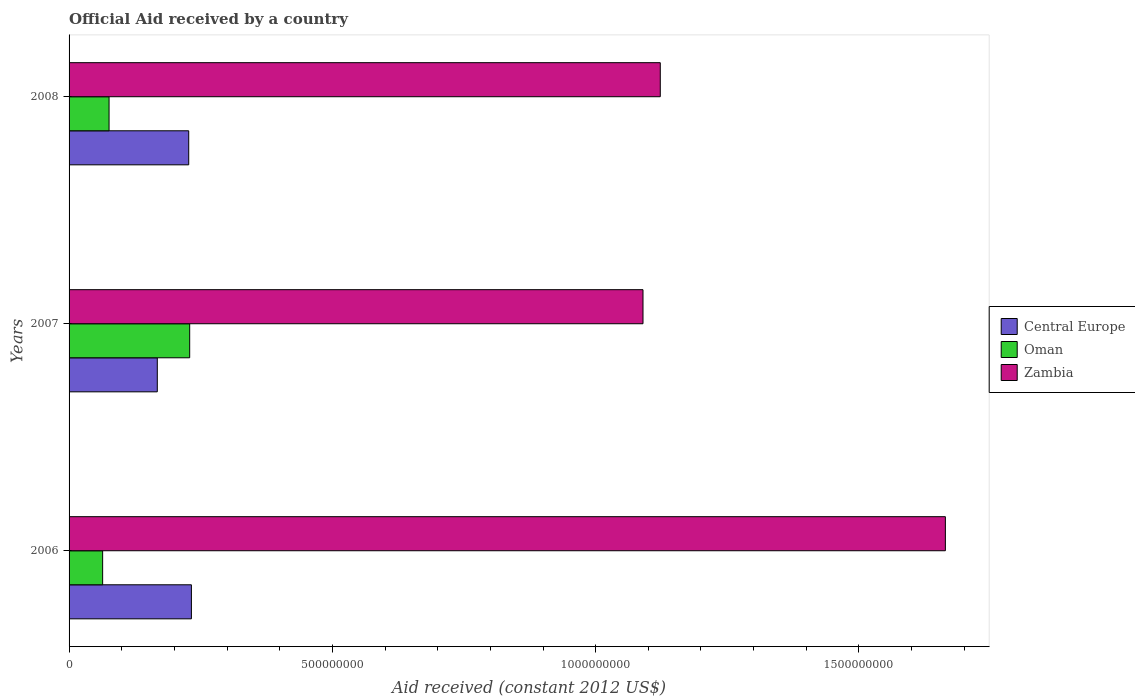How many different coloured bars are there?
Provide a succinct answer. 3. How many groups of bars are there?
Your answer should be compact. 3. Are the number of bars per tick equal to the number of legend labels?
Your answer should be compact. Yes. Are the number of bars on each tick of the Y-axis equal?
Ensure brevity in your answer.  Yes. How many bars are there on the 3rd tick from the top?
Your answer should be very brief. 3. How many bars are there on the 2nd tick from the bottom?
Offer a terse response. 3. In how many cases, is the number of bars for a given year not equal to the number of legend labels?
Provide a short and direct response. 0. What is the net official aid received in Oman in 2006?
Your answer should be very brief. 6.37e+07. Across all years, what is the maximum net official aid received in Zambia?
Keep it short and to the point. 1.66e+09. Across all years, what is the minimum net official aid received in Zambia?
Ensure brevity in your answer.  1.09e+09. What is the total net official aid received in Oman in the graph?
Provide a short and direct response. 3.69e+08. What is the difference between the net official aid received in Zambia in 2007 and that in 2008?
Your answer should be compact. -3.28e+07. What is the difference between the net official aid received in Oman in 2006 and the net official aid received in Central Europe in 2008?
Ensure brevity in your answer.  -1.63e+08. What is the average net official aid received in Zambia per year?
Keep it short and to the point. 1.29e+09. In the year 2007, what is the difference between the net official aid received in Oman and net official aid received in Zambia?
Offer a terse response. -8.61e+08. What is the ratio of the net official aid received in Zambia in 2006 to that in 2007?
Offer a very short reply. 1.53. Is the difference between the net official aid received in Oman in 2006 and 2007 greater than the difference between the net official aid received in Zambia in 2006 and 2007?
Offer a very short reply. No. What is the difference between the highest and the second highest net official aid received in Central Europe?
Provide a short and direct response. 5.09e+06. What is the difference between the highest and the lowest net official aid received in Central Europe?
Your answer should be very brief. 6.48e+07. In how many years, is the net official aid received in Oman greater than the average net official aid received in Oman taken over all years?
Your answer should be very brief. 1. Is the sum of the net official aid received in Zambia in 2007 and 2008 greater than the maximum net official aid received in Oman across all years?
Give a very brief answer. Yes. What does the 1st bar from the top in 2008 represents?
Keep it short and to the point. Zambia. What does the 2nd bar from the bottom in 2008 represents?
Give a very brief answer. Oman. Is it the case that in every year, the sum of the net official aid received in Zambia and net official aid received in Central Europe is greater than the net official aid received in Oman?
Keep it short and to the point. Yes. How many years are there in the graph?
Offer a very short reply. 3. What is the difference between two consecutive major ticks on the X-axis?
Give a very brief answer. 5.00e+08. Are the values on the major ticks of X-axis written in scientific E-notation?
Offer a terse response. No. Does the graph contain any zero values?
Your answer should be very brief. No. Where does the legend appear in the graph?
Keep it short and to the point. Center right. How are the legend labels stacked?
Provide a short and direct response. Vertical. What is the title of the graph?
Offer a very short reply. Official Aid received by a country. What is the label or title of the X-axis?
Your answer should be compact. Aid received (constant 2012 US$). What is the label or title of the Y-axis?
Provide a succinct answer. Years. What is the Aid received (constant 2012 US$) of Central Europe in 2006?
Keep it short and to the point. 2.32e+08. What is the Aid received (constant 2012 US$) in Oman in 2006?
Your answer should be compact. 6.37e+07. What is the Aid received (constant 2012 US$) of Zambia in 2006?
Offer a terse response. 1.66e+09. What is the Aid received (constant 2012 US$) of Central Europe in 2007?
Provide a short and direct response. 1.68e+08. What is the Aid received (constant 2012 US$) in Oman in 2007?
Make the answer very short. 2.29e+08. What is the Aid received (constant 2012 US$) in Zambia in 2007?
Provide a succinct answer. 1.09e+09. What is the Aid received (constant 2012 US$) of Central Europe in 2008?
Provide a succinct answer. 2.27e+08. What is the Aid received (constant 2012 US$) in Oman in 2008?
Your response must be concise. 7.60e+07. What is the Aid received (constant 2012 US$) in Zambia in 2008?
Keep it short and to the point. 1.12e+09. Across all years, what is the maximum Aid received (constant 2012 US$) in Central Europe?
Make the answer very short. 2.32e+08. Across all years, what is the maximum Aid received (constant 2012 US$) in Oman?
Your response must be concise. 2.29e+08. Across all years, what is the maximum Aid received (constant 2012 US$) in Zambia?
Provide a succinct answer. 1.66e+09. Across all years, what is the minimum Aid received (constant 2012 US$) of Central Europe?
Make the answer very short. 1.68e+08. Across all years, what is the minimum Aid received (constant 2012 US$) in Oman?
Offer a terse response. 6.37e+07. Across all years, what is the minimum Aid received (constant 2012 US$) in Zambia?
Give a very brief answer. 1.09e+09. What is the total Aid received (constant 2012 US$) of Central Europe in the graph?
Offer a terse response. 6.27e+08. What is the total Aid received (constant 2012 US$) in Oman in the graph?
Ensure brevity in your answer.  3.69e+08. What is the total Aid received (constant 2012 US$) in Zambia in the graph?
Your answer should be compact. 3.88e+09. What is the difference between the Aid received (constant 2012 US$) of Central Europe in 2006 and that in 2007?
Keep it short and to the point. 6.48e+07. What is the difference between the Aid received (constant 2012 US$) of Oman in 2006 and that in 2007?
Your response must be concise. -1.65e+08. What is the difference between the Aid received (constant 2012 US$) in Zambia in 2006 and that in 2007?
Provide a short and direct response. 5.74e+08. What is the difference between the Aid received (constant 2012 US$) in Central Europe in 2006 and that in 2008?
Keep it short and to the point. 5.09e+06. What is the difference between the Aid received (constant 2012 US$) in Oman in 2006 and that in 2008?
Offer a very short reply. -1.22e+07. What is the difference between the Aid received (constant 2012 US$) of Zambia in 2006 and that in 2008?
Ensure brevity in your answer.  5.41e+08. What is the difference between the Aid received (constant 2012 US$) of Central Europe in 2007 and that in 2008?
Give a very brief answer. -5.97e+07. What is the difference between the Aid received (constant 2012 US$) in Oman in 2007 and that in 2008?
Your response must be concise. 1.53e+08. What is the difference between the Aid received (constant 2012 US$) of Zambia in 2007 and that in 2008?
Make the answer very short. -3.28e+07. What is the difference between the Aid received (constant 2012 US$) of Central Europe in 2006 and the Aid received (constant 2012 US$) of Oman in 2007?
Your answer should be compact. 3.25e+06. What is the difference between the Aid received (constant 2012 US$) of Central Europe in 2006 and the Aid received (constant 2012 US$) of Zambia in 2007?
Provide a succinct answer. -8.58e+08. What is the difference between the Aid received (constant 2012 US$) of Oman in 2006 and the Aid received (constant 2012 US$) of Zambia in 2007?
Ensure brevity in your answer.  -1.03e+09. What is the difference between the Aid received (constant 2012 US$) in Central Europe in 2006 and the Aid received (constant 2012 US$) in Oman in 2008?
Your answer should be compact. 1.56e+08. What is the difference between the Aid received (constant 2012 US$) of Central Europe in 2006 and the Aid received (constant 2012 US$) of Zambia in 2008?
Give a very brief answer. -8.90e+08. What is the difference between the Aid received (constant 2012 US$) of Oman in 2006 and the Aid received (constant 2012 US$) of Zambia in 2008?
Provide a succinct answer. -1.06e+09. What is the difference between the Aid received (constant 2012 US$) in Central Europe in 2007 and the Aid received (constant 2012 US$) in Oman in 2008?
Offer a very short reply. 9.16e+07. What is the difference between the Aid received (constant 2012 US$) of Central Europe in 2007 and the Aid received (constant 2012 US$) of Zambia in 2008?
Give a very brief answer. -9.55e+08. What is the difference between the Aid received (constant 2012 US$) in Oman in 2007 and the Aid received (constant 2012 US$) in Zambia in 2008?
Provide a succinct answer. -8.94e+08. What is the average Aid received (constant 2012 US$) of Central Europe per year?
Make the answer very short. 2.09e+08. What is the average Aid received (constant 2012 US$) in Oman per year?
Offer a very short reply. 1.23e+08. What is the average Aid received (constant 2012 US$) of Zambia per year?
Give a very brief answer. 1.29e+09. In the year 2006, what is the difference between the Aid received (constant 2012 US$) of Central Europe and Aid received (constant 2012 US$) of Oman?
Your answer should be compact. 1.69e+08. In the year 2006, what is the difference between the Aid received (constant 2012 US$) of Central Europe and Aid received (constant 2012 US$) of Zambia?
Offer a very short reply. -1.43e+09. In the year 2006, what is the difference between the Aid received (constant 2012 US$) of Oman and Aid received (constant 2012 US$) of Zambia?
Your answer should be compact. -1.60e+09. In the year 2007, what is the difference between the Aid received (constant 2012 US$) in Central Europe and Aid received (constant 2012 US$) in Oman?
Your answer should be compact. -6.15e+07. In the year 2007, what is the difference between the Aid received (constant 2012 US$) in Central Europe and Aid received (constant 2012 US$) in Zambia?
Offer a very short reply. -9.22e+08. In the year 2007, what is the difference between the Aid received (constant 2012 US$) in Oman and Aid received (constant 2012 US$) in Zambia?
Your response must be concise. -8.61e+08. In the year 2008, what is the difference between the Aid received (constant 2012 US$) of Central Europe and Aid received (constant 2012 US$) of Oman?
Give a very brief answer. 1.51e+08. In the year 2008, what is the difference between the Aid received (constant 2012 US$) in Central Europe and Aid received (constant 2012 US$) in Zambia?
Provide a succinct answer. -8.95e+08. In the year 2008, what is the difference between the Aid received (constant 2012 US$) of Oman and Aid received (constant 2012 US$) of Zambia?
Provide a succinct answer. -1.05e+09. What is the ratio of the Aid received (constant 2012 US$) in Central Europe in 2006 to that in 2007?
Offer a terse response. 1.39. What is the ratio of the Aid received (constant 2012 US$) in Oman in 2006 to that in 2007?
Your response must be concise. 0.28. What is the ratio of the Aid received (constant 2012 US$) in Zambia in 2006 to that in 2007?
Ensure brevity in your answer.  1.53. What is the ratio of the Aid received (constant 2012 US$) of Central Europe in 2006 to that in 2008?
Your response must be concise. 1.02. What is the ratio of the Aid received (constant 2012 US$) of Oman in 2006 to that in 2008?
Offer a very short reply. 0.84. What is the ratio of the Aid received (constant 2012 US$) of Zambia in 2006 to that in 2008?
Your response must be concise. 1.48. What is the ratio of the Aid received (constant 2012 US$) of Central Europe in 2007 to that in 2008?
Give a very brief answer. 0.74. What is the ratio of the Aid received (constant 2012 US$) in Oman in 2007 to that in 2008?
Your response must be concise. 3.02. What is the ratio of the Aid received (constant 2012 US$) in Zambia in 2007 to that in 2008?
Your answer should be compact. 0.97. What is the difference between the highest and the second highest Aid received (constant 2012 US$) of Central Europe?
Your answer should be compact. 5.09e+06. What is the difference between the highest and the second highest Aid received (constant 2012 US$) of Oman?
Provide a succinct answer. 1.53e+08. What is the difference between the highest and the second highest Aid received (constant 2012 US$) of Zambia?
Provide a short and direct response. 5.41e+08. What is the difference between the highest and the lowest Aid received (constant 2012 US$) of Central Europe?
Give a very brief answer. 6.48e+07. What is the difference between the highest and the lowest Aid received (constant 2012 US$) of Oman?
Provide a short and direct response. 1.65e+08. What is the difference between the highest and the lowest Aid received (constant 2012 US$) in Zambia?
Provide a succinct answer. 5.74e+08. 